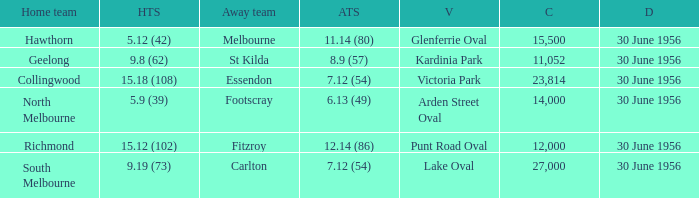What away team has a home team score of 15.18 (108)? Essendon. 